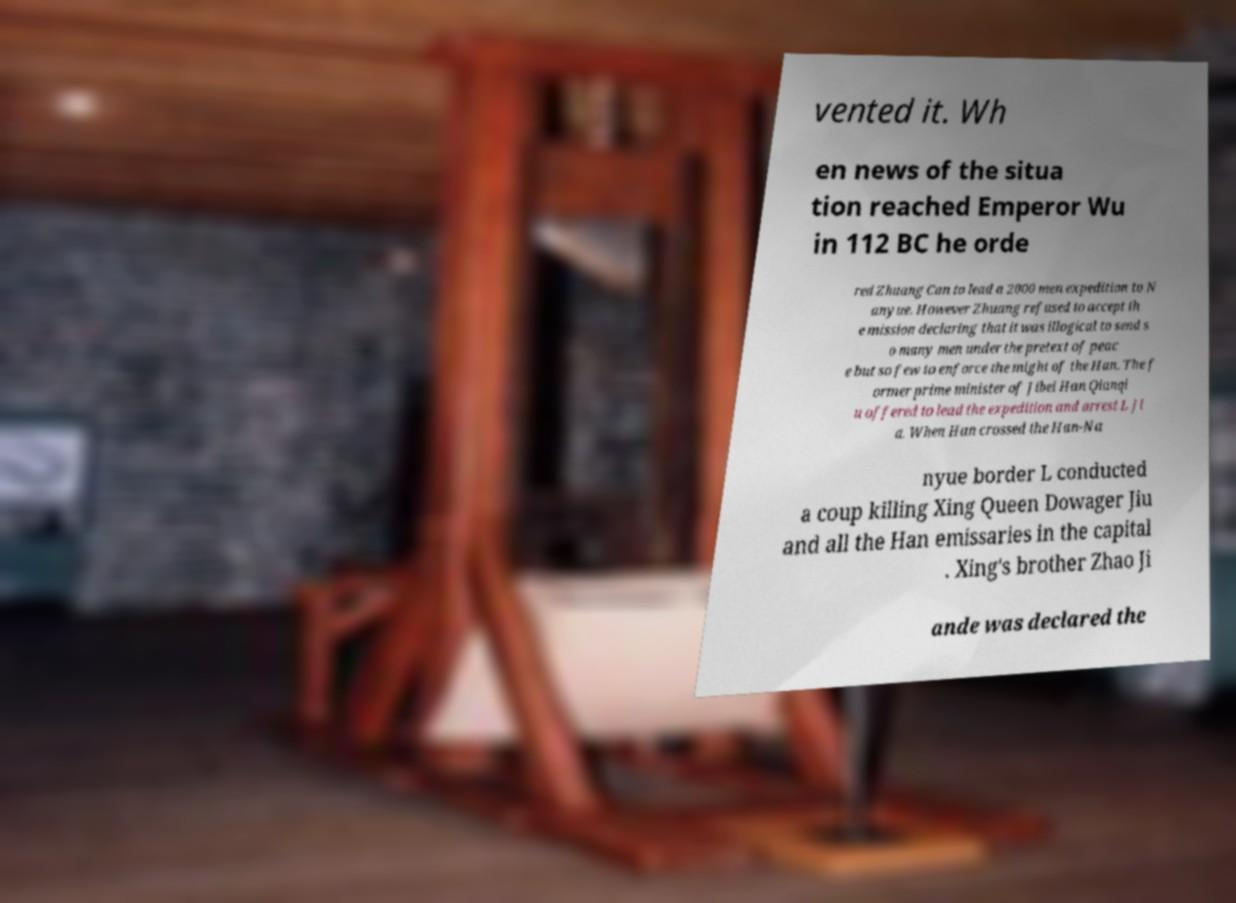Can you accurately transcribe the text from the provided image for me? vented it. Wh en news of the situa tion reached Emperor Wu in 112 BC he orde red Zhuang Can to lead a 2000 men expedition to N anyue. However Zhuang refused to accept th e mission declaring that it was illogical to send s o many men under the pretext of peac e but so few to enforce the might of the Han. The f ormer prime minister of Jibei Han Qianqi u offered to lead the expedition and arrest L Ji a. When Han crossed the Han-Na nyue border L conducted a coup killing Xing Queen Dowager Jiu and all the Han emissaries in the capital . Xing's brother Zhao Ji ande was declared the 